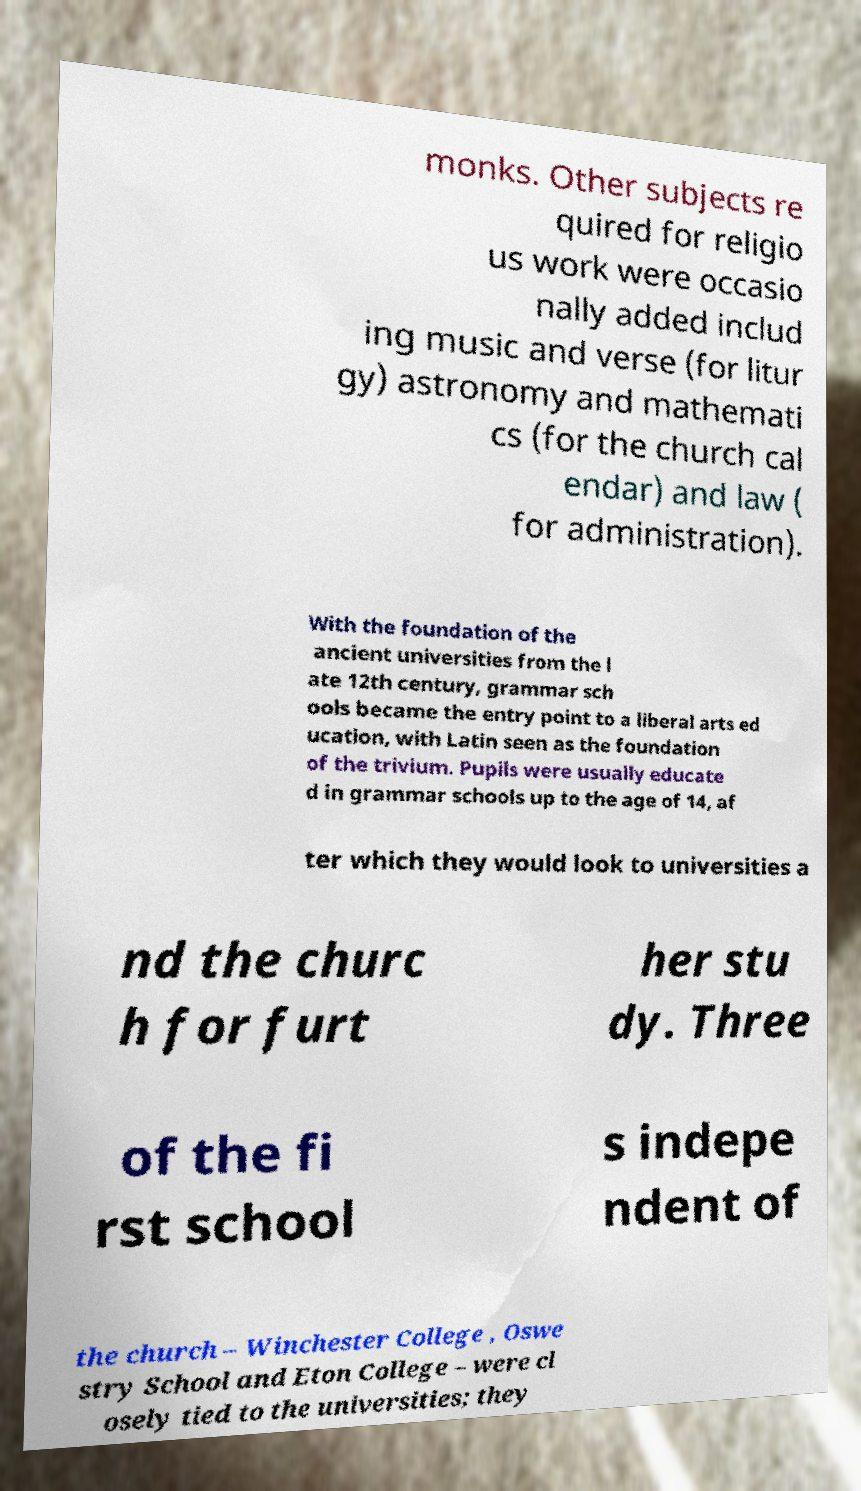Could you extract and type out the text from this image? monks. Other subjects re quired for religio us work were occasio nally added includ ing music and verse (for litur gy) astronomy and mathemati cs (for the church cal endar) and law ( for administration). With the foundation of the ancient universities from the l ate 12th century, grammar sch ools became the entry point to a liberal arts ed ucation, with Latin seen as the foundation of the trivium. Pupils were usually educate d in grammar schools up to the age of 14, af ter which they would look to universities a nd the churc h for furt her stu dy. Three of the fi rst school s indepe ndent of the church – Winchester College , Oswe stry School and Eton College – were cl osely tied to the universities; they 